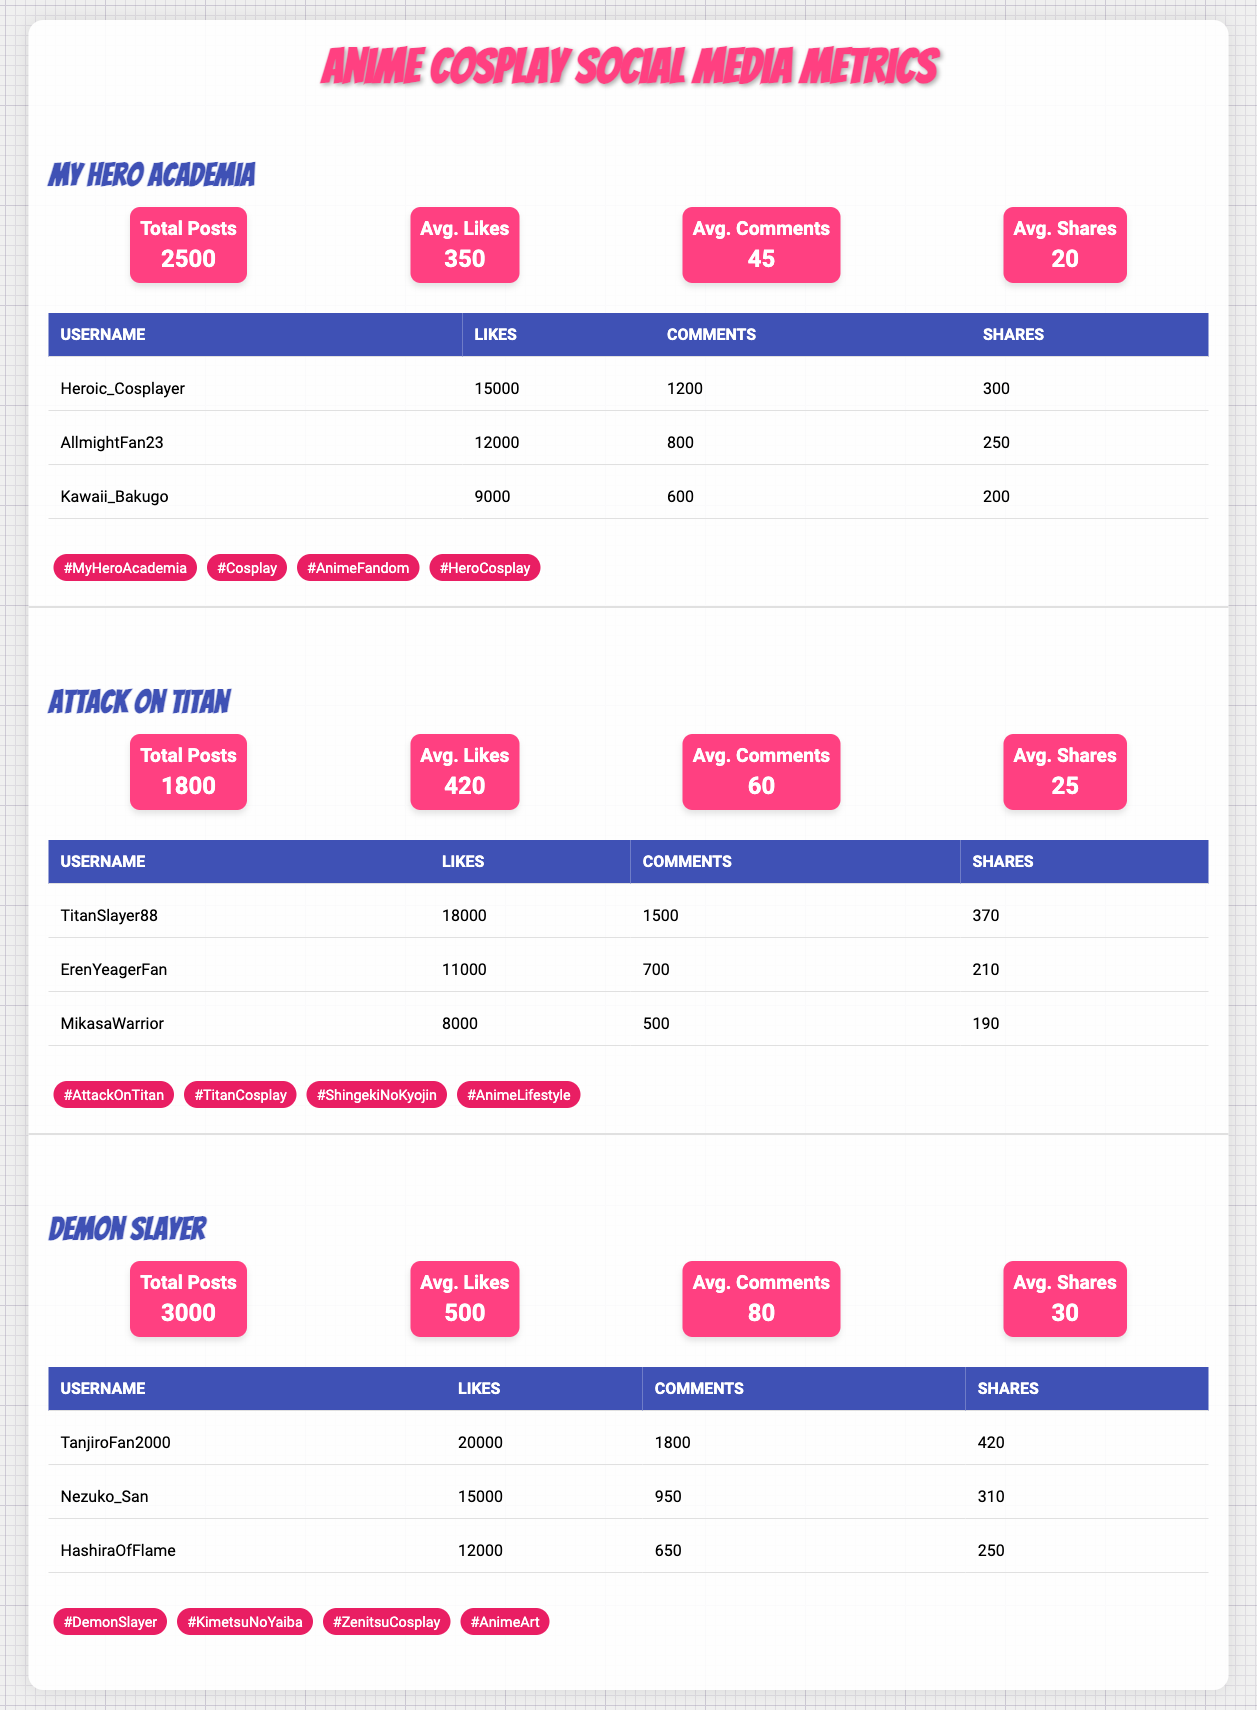What is the total number of cosplay posts for "My Hero Academia"? The table states that the total posts for "My Hero Academia" are indicated under the "Total Posts" section, which is listed as 2500.
Answer: 2500 Who is the top cosplayer in "Demon Slayer" based on the number of likes? By looking at the table, "TanjiroFan2000" has the highest number of likes in "Demon Slayer" with 20000 likes, compared to the others in this category.
Answer: TanjiroFan2000 What is the average number of shares for cosplay posts related to "Attack on Titan"? The average shares are found in the engagement metrics for "Attack on Titan," which states 25 as the average number of shares per post.
Answer: 25 Is the average number of comments for "Demon Slayer" higher than that of "My Hero Academia"? The average comments for "Demon Slayer" is 80, while for "My Hero Academia," it is 45. Since 80 is greater than 45, the statement is true.
Answer: Yes What is the sum of all likes received by the top cosplayers in "My Hero Academia"? The likes for the top three cosplayers are 15000, 12000, and 9000. Adding these values gives 15000 + 12000 + 9000 = 36000 total likes.
Answer: 36000 Which anime series has the highest average number of likes per post? By comparing the average likes of each series: "My Hero Academia" has 350, "Attack on Titan" has 420, and "Demon Slayer" has 500. "Demon Slayer" has the highest average likes.
Answer: Demon Slayer What percentage of the total posts for "Attack on Titan" has the highest liking cosplayer contributed? The top cosplayer "TitanSlayer88" has 18000 likes, while total posts for "Attack on Titan" are 1800. The percentage of contribution is (18000/1800) * 100 = 1000%.
Answer: 1000% Are there any cosplayers from "Demon Slayer" who have received more than 300 shares? In the table for "Demon Slayer," we see "TanjiroFan2000" with 420 shares and "Nezuko_San" with 310 shares, meaning there are cosplayers who received more than 300 shares.
Answer: Yes 